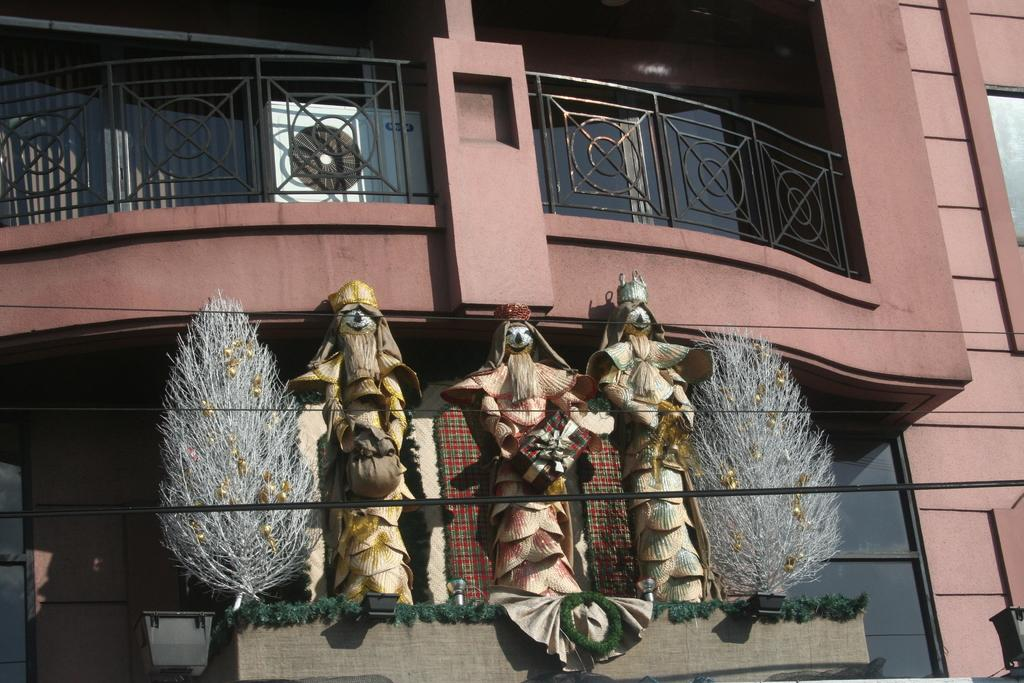What type of building is shown in the image? The building in the image has glass walls. Are there any safety features visible on the building? Yes, the building has railing. What can be seen in front of the building? There are statues and plants in front of the building. What additional decorative elements are present in the image? There are decorative items in the image. What religion is practiced inside the building in the image? There is no information about the religion practiced inside the building in the image. What color is the answer to the question "What is the meaning of life?" in the image? The question "What is the meaning of life?" is not present in the image, and therefore, there is no answer to determine its color. 